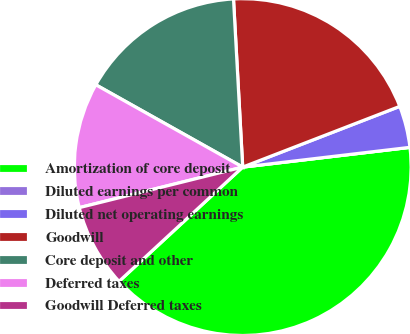Convert chart to OTSL. <chart><loc_0><loc_0><loc_500><loc_500><pie_chart><fcel>Amortization of core deposit<fcel>Diluted earnings per common<fcel>Diluted net operating earnings<fcel>Goodwill<fcel>Core deposit and other<fcel>Deferred taxes<fcel>Goodwill Deferred taxes<nl><fcel>40.0%<fcel>0.0%<fcel>4.0%<fcel>20.0%<fcel>16.0%<fcel>12.0%<fcel>8.0%<nl></chart> 